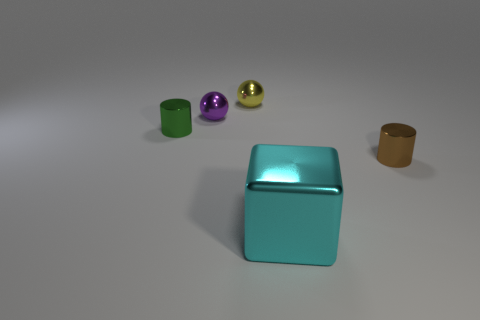Is there anything else that is the same shape as the big thing?
Offer a very short reply. No. There is another small thing that is the same shape as the yellow thing; what color is it?
Give a very brief answer. Purple. What number of shiny cylinders are the same color as the big metallic cube?
Make the answer very short. 0. There is a object to the right of the large metal block; is its size the same as the metal object that is in front of the small brown cylinder?
Your answer should be very brief. No. Do the yellow object and the shiny ball that is in front of the tiny yellow ball have the same size?
Offer a very short reply. Yes. What size is the purple metal object?
Your response must be concise. Small. What is the color of the block that is made of the same material as the tiny yellow thing?
Your answer should be compact. Cyan. What number of other tiny balls are made of the same material as the small purple ball?
Offer a terse response. 1. How many objects are green shiny cylinders or tiny metallic objects that are behind the green cylinder?
Ensure brevity in your answer.  3. There is another metal cylinder that is the same size as the brown cylinder; what color is it?
Your answer should be compact. Green. 